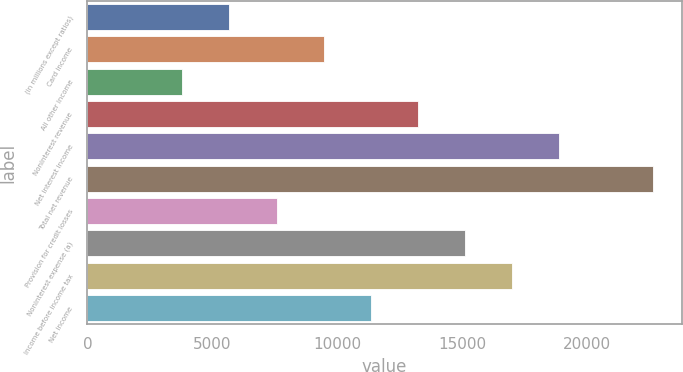Convert chart to OTSL. <chart><loc_0><loc_0><loc_500><loc_500><bar_chart><fcel>(in millions except ratios)<fcel>Card income<fcel>All other income<fcel>Noninterest revenue<fcel>Net interest income<fcel>Total net revenue<fcel>Provision for credit losses<fcel>Noninterest expense (a)<fcel>Income before income tax<fcel>Net income<nl><fcel>5688.4<fcel>9460<fcel>3802.6<fcel>13231.6<fcel>18889<fcel>22660.6<fcel>7574.2<fcel>15117.4<fcel>17003.2<fcel>11345.8<nl></chart> 